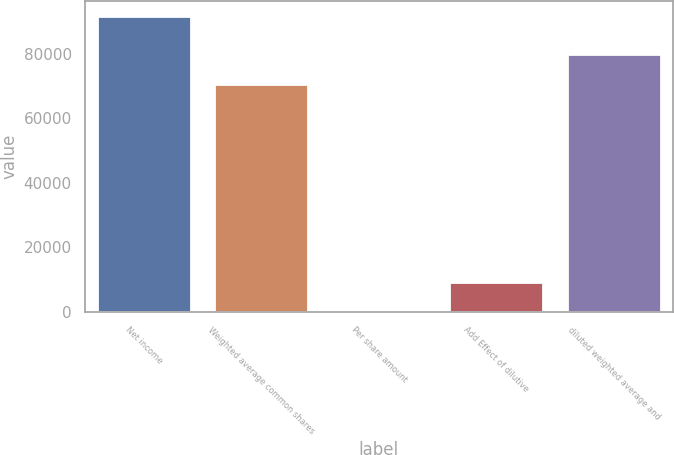Convert chart to OTSL. <chart><loc_0><loc_0><loc_500><loc_500><bar_chart><fcel>Net income<fcel>Weighted average common shares<fcel>Per share amount<fcel>Add Effect of dilutive<fcel>diluted weighted average and<nl><fcel>91696<fcel>70647<fcel>1.3<fcel>9170.77<fcel>79816.5<nl></chart> 